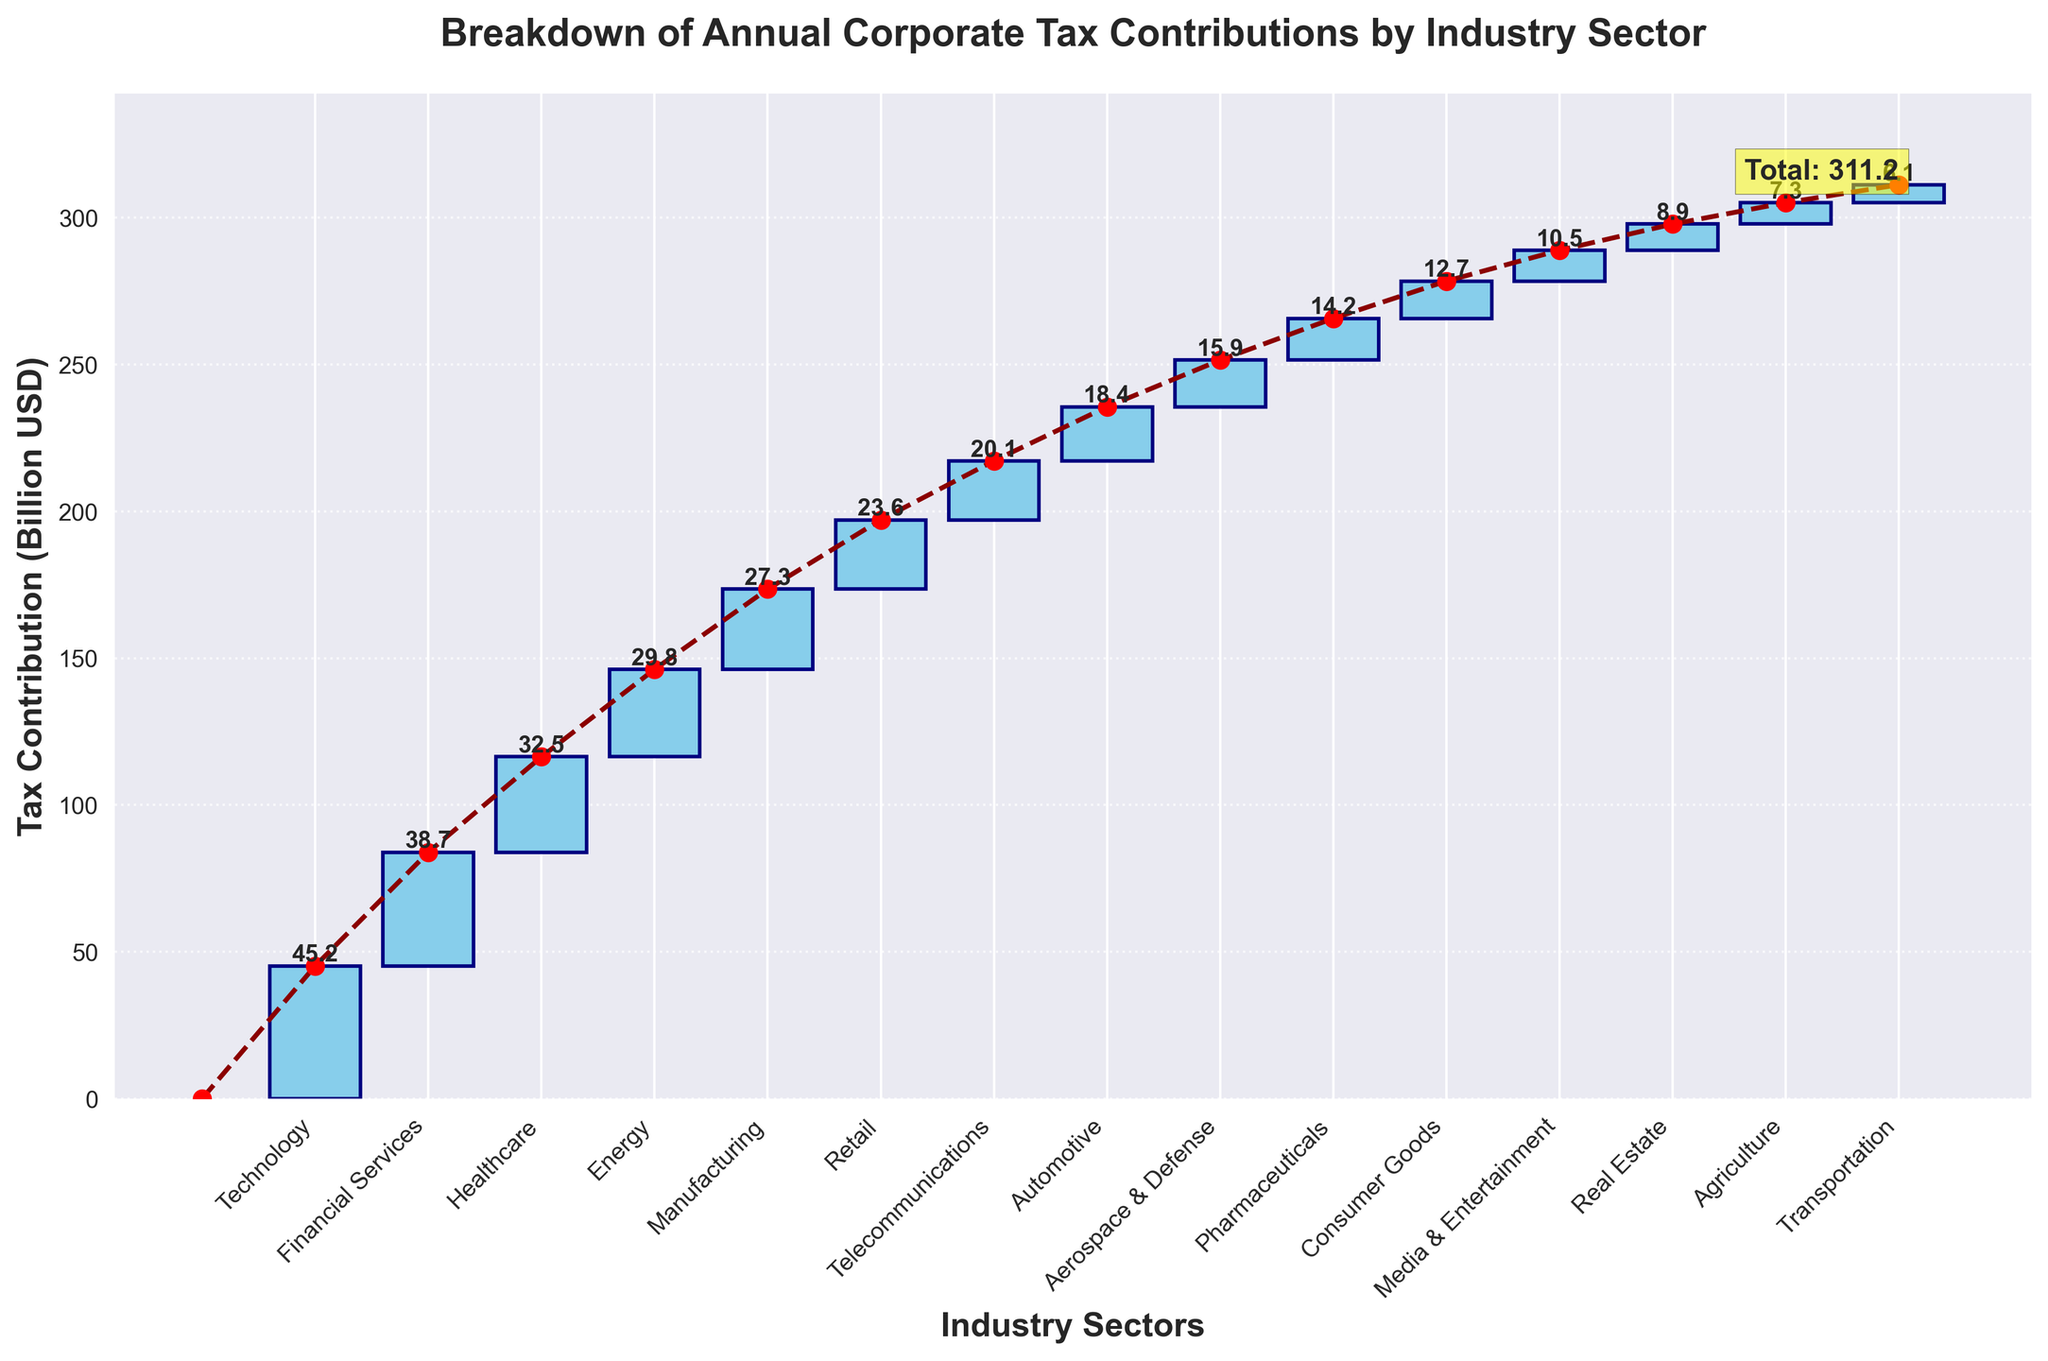What is the title of the chart? The title of the chart is typically located at the top and provides a summary of what the chart represents. Here, it reads "Breakdown of Annual Corporate Tax Contributions by Industry Sector."
Answer: Breakdown of Annual Corporate Tax Contributions by Industry Sector Which industry has the highest tax contribution? The highest bar represents the industry with the highest tax contribution. The chart shows that "Technology" has the highest value, indicated by the tallest bar.
Answer: Technology How much is the total tax contribution by all industries? The total tax contribution is mentioned as an annotated value at the end of the accumulation line or near the last industry. It is also in the data table, which sums up to 311.2 billion USD.
Answer: 311.2 billion USD What are the tax contributions of the Healthcare and Energy sectors combined? To find the combined contributions, add the values for the Healthcare (32.5 billion USD) and Energy (29.8 billion USD) sectors.
Answer: 32.5 + 29.8 = 62.3 billion USD Which industries have tax contributions greater than 30 billion USD? Look for bars with values greater than 30 billion USD. The chart shows that the Technology, Financial Services, and Healthcare sectors meet this criterion.
Answer: Technology, Financial Services, Healthcare Which industry has the lowest tax contribution, and what is its value? The smallest bar represents the industry with the lowest tax contribution. The chart indicates that "Transportation" has the lowest value, at 6.1 billion USD.
Answer: Transportation, 6.1 billion USD How many industry sectors are listed in the chart? Count the number of bars or x-axis labels representing different industries. The chart displays 15 industry sectors.
Answer: 15 What is the difference in tax contribution between the Manufacturing and Retail sectors? Subtract the tax contribution of Retail (23.6 billion USD) from that of Manufacturing (27.3 billion USD).
Answer: 27.3 - 23.6 = 3.7 billion USD Which industry sector is positioned in the middle in terms of tax contribution, and what is its value? Find the median industry sector by identifying the middle value in a sorted list of contributions. Sorting the values, the middle value (8th position) is "Automotive" with 18.4 billion USD.
Answer: Automotive, 18.4 billion USD 